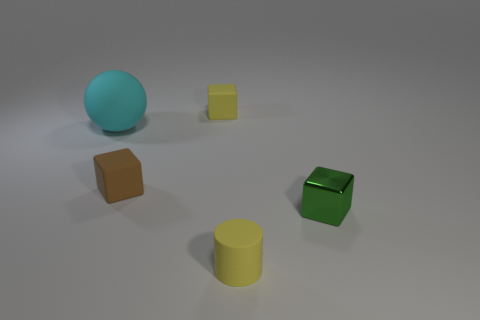Add 3 big purple cylinders. How many objects exist? 8 Subtract all spheres. How many objects are left? 4 Subtract 0 red spheres. How many objects are left? 5 Subtract all tiny brown cubes. Subtract all cyan matte things. How many objects are left? 3 Add 5 cubes. How many cubes are left? 8 Add 3 small purple cylinders. How many small purple cylinders exist? 3 